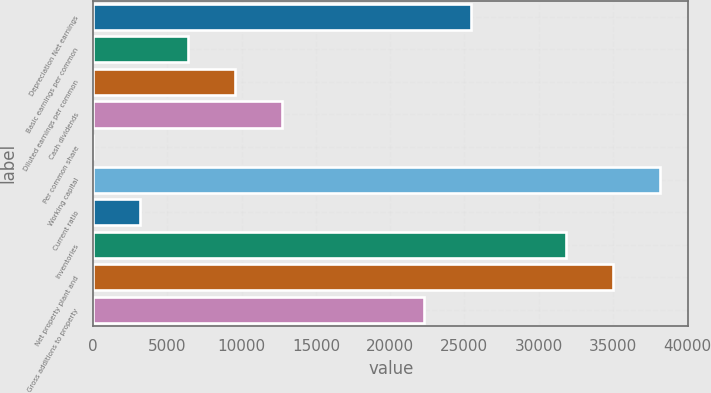Convert chart. <chart><loc_0><loc_0><loc_500><loc_500><bar_chart><fcel>Depreciation Net earnings<fcel>Basic earnings per common<fcel>Diluted earnings per common<fcel>Cash dividends<fcel>Per common share<fcel>Working capital<fcel>Current ratio<fcel>Inventories<fcel>Net property plant and<fcel>Gross additions to property<nl><fcel>25446.5<fcel>6362.06<fcel>9542.8<fcel>12723.5<fcel>0.58<fcel>38169.5<fcel>3181.32<fcel>31808<fcel>34988.7<fcel>22265.8<nl></chart> 